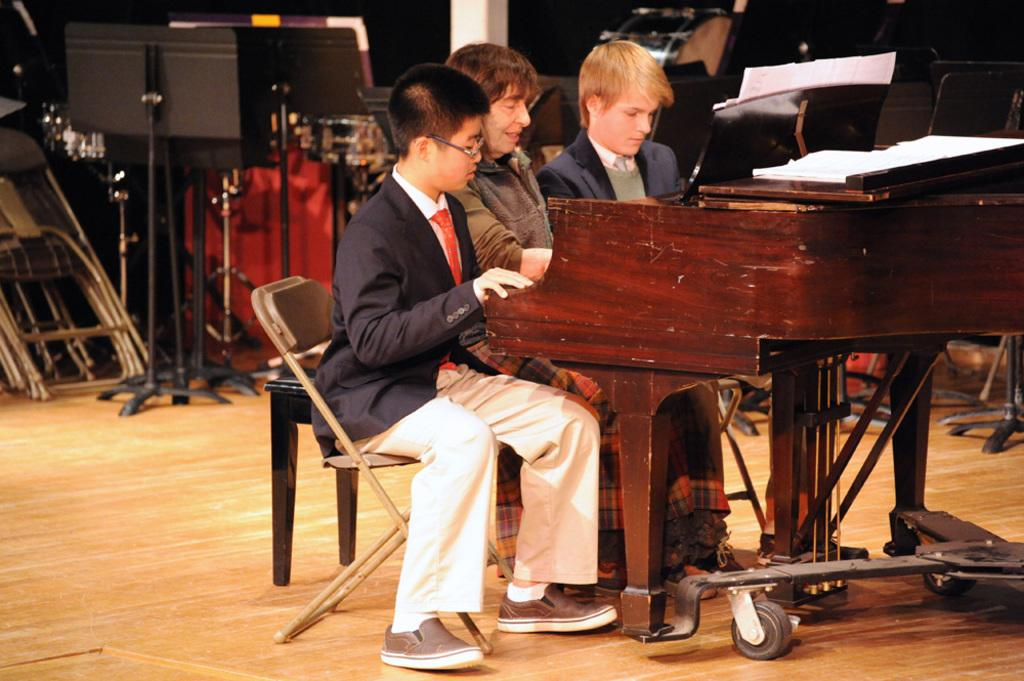How many men are in the image? There are three men in the image. What are the men doing in the image? The men are sitting on chairs and playing a piano. What is on the piano? There is paper on the piano. What can be seen in the background of the image? In the background, there are pillars, stands, chairs, drums, and other pianos. What type of nail is being used to play the piano in the image? There is no nail being used to play the piano in the image; the men are using their hands to play the piano. Can you see a chessboard in the image? There is no chessboard present in the image. 